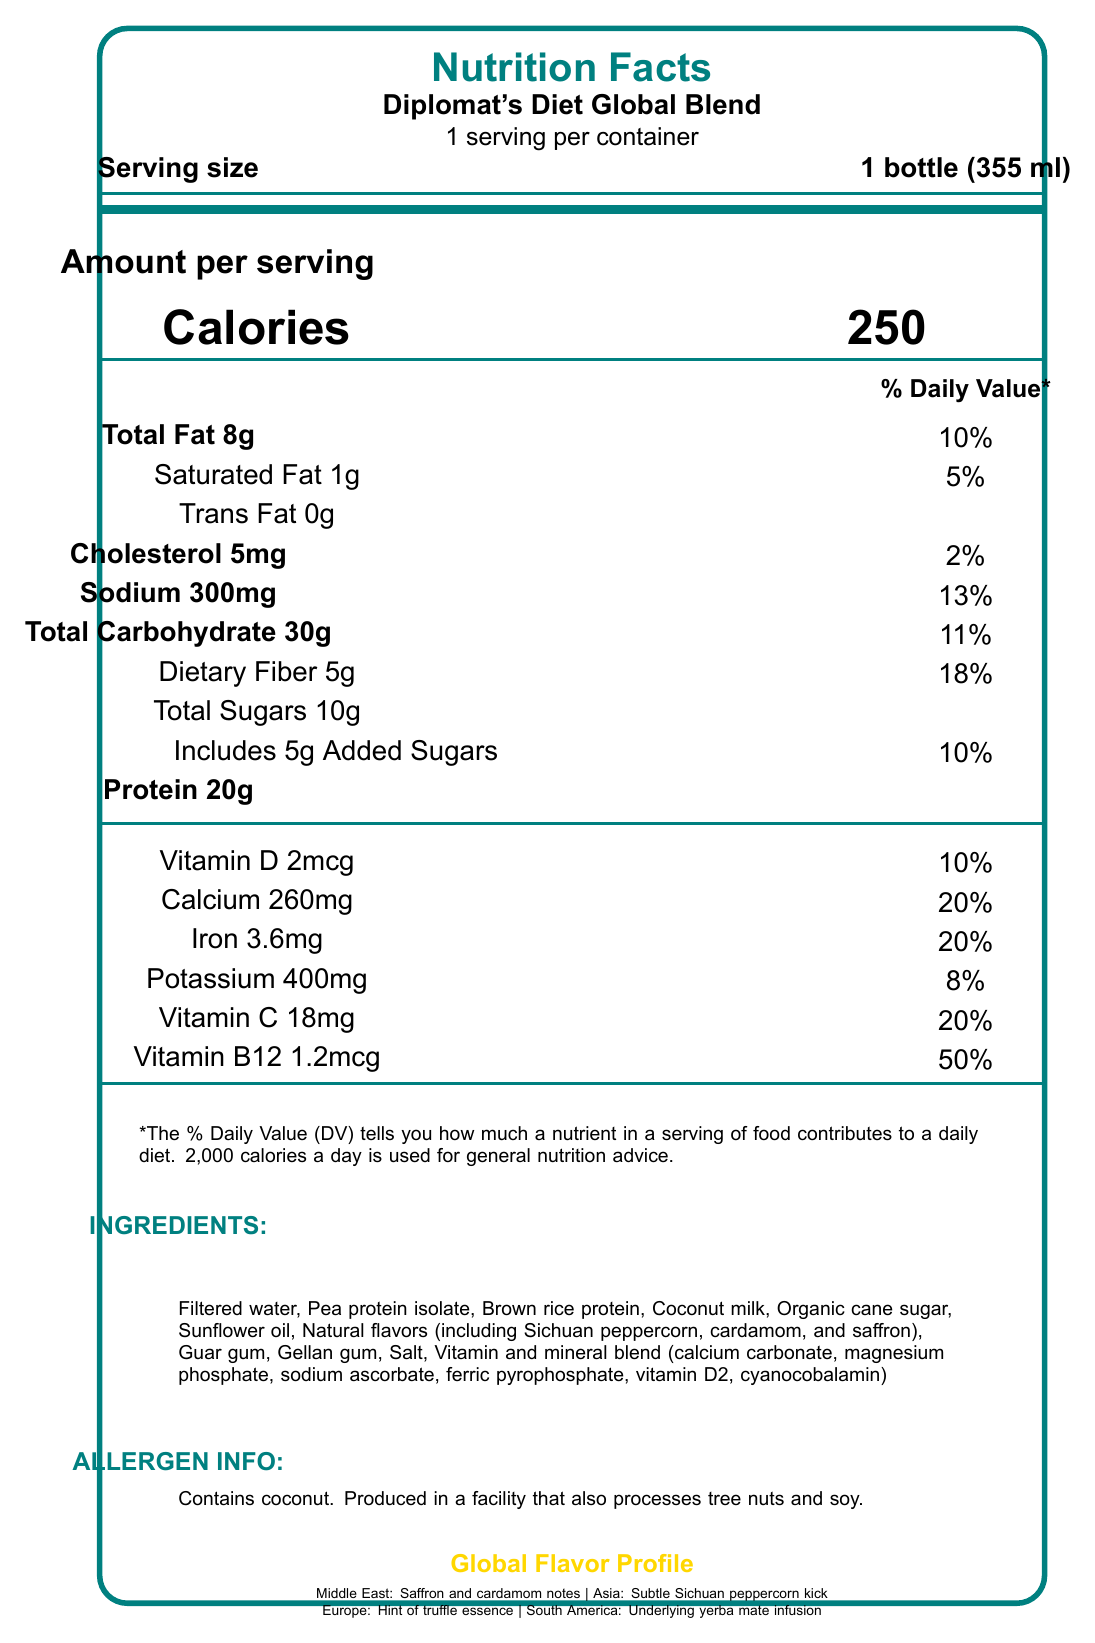What is the serving size of Diplomat's Diet Global Blend? The serving size is explicitly stated as "1 bottle (355 ml)" in the document.
Answer: 1 bottle (355 ml) How many calories are in one serving of Diplomat's Diet Global Blend? The document lists the calorie content under "Amount per serving" as 250 calories.
Answer: 250 What percentage of the daily value for Vitamin D does one serving provide? The percentage of daily value for Vitamin D is shown as 10% in the document.
Answer: 10% How much protein is in a serving? The protein content per serving is stated as 20 grams in the document.
Answer: 20g Does the product contain any allergens, and if so, which ones? The allergen information is provided in the document, stating that it contains coconut and is produced in a facility that processes tree nuts and soy.
Answer: Yes, contains coconut. How much added sugar is in one serving? The document lists 5 grams of added sugar in one serving.
Answer: 5g Which one of the following is NOT an ingredient in the Diplomat's Diet Global Blend? A. Brown rice protein B. Palm oil C. Guar gum The listed ingredients include brown rice protein and guar gum but not palm oil.
Answer: B What is the shelf life of the product? A. 6 months B. 12 months C. 18 months D. 24 months The shelf life is stated as 12 months when stored at room temperature.
Answer: B Is there any information about the product enhancing cognitive performance? The document mentions that the product contains a nootropic blend for enhanced cognitive performance.
Answer: Yes To what percentage of the daily value does the iron content in one serving correspond? The percentage of daily value for iron is clearly stated as 20%.
Answer: 20% Does this drink have any flavor profiles from Europe? The geopolitical flavor profile mentions a hint of truffle essence representing Europe.
Answer: Yes Which vitamin has the highest percentage of daily value in one serving? A. Vitamin C B. Vitamin D C. Vitamin B12 D. Calcium Vitamin B12 has the highest percentage of daily value at 50%.
Answer: C Can the vitamin A content in one serving be found in the document? The document explicitly states that it is not a significant source of vitamin A.
Answer: No, not a significant source What are the main geopolitical flavors included in the Diplomat's Diet Global Blend? The document lists these flavor profiles under the Global Flavor Profile section.
Answer: Middle East: Saffron and cardamom, Asia: Sichuan peppercorn, Europe: Truffle essence, South America: Yerba mate Who distributes Diplomat's Diet Global Blend? The distribution information is clearly stated in the document.
Answer: Diplomatic Corps Catering, Washington D.C., USA What is the sodium content per serving? The sodium content is listed as 300mg per serving in the document.
Answer: 300mg Is the product a significant source of vitamin A? The disclaimer clearly states that it is not a significant source of vitamin A.
Answer: No Summarize the main information provided in the Nutrition Facts Label for Diplomat's Diet Global Blend. The summary covers the product name, serving size, key nutritional information, allergens, flavors, manufacturer, and distributor as provided in the document.
Answer: Diplomat's Diet Global Blend is a meal replacement drink with international flavor profiles, including saffron, cardamom, Sichuan peppercorn, truffle essence, and yerba mate. A serving size is 1 bottle (355 ml) with 250 calories. Nutrients per serving are documented with percentages of daily values. The drink contains coconut and is manufactured by Global Nutrition Solutions in Geneva, Switzerland and distributed by Diplomatic Corps Catering in Washington D.C., USA. 